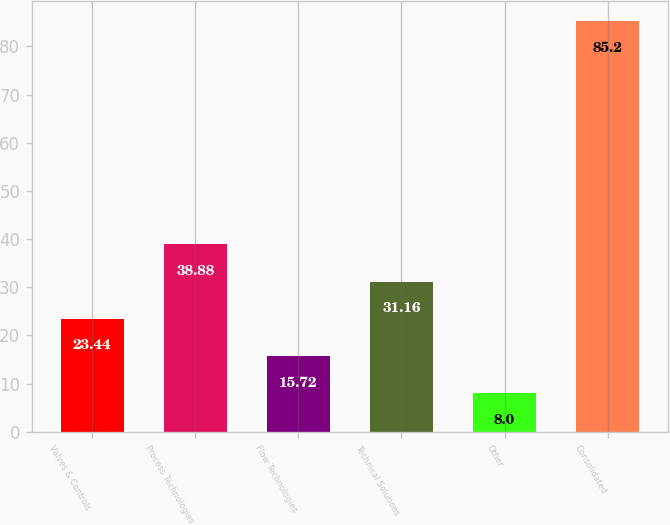<chart> <loc_0><loc_0><loc_500><loc_500><bar_chart><fcel>Valves & Controls<fcel>Process Technologies<fcel>Flow Technologies<fcel>Technical Solutions<fcel>Other<fcel>Consolidated<nl><fcel>23.44<fcel>38.88<fcel>15.72<fcel>31.16<fcel>8<fcel>85.2<nl></chart> 